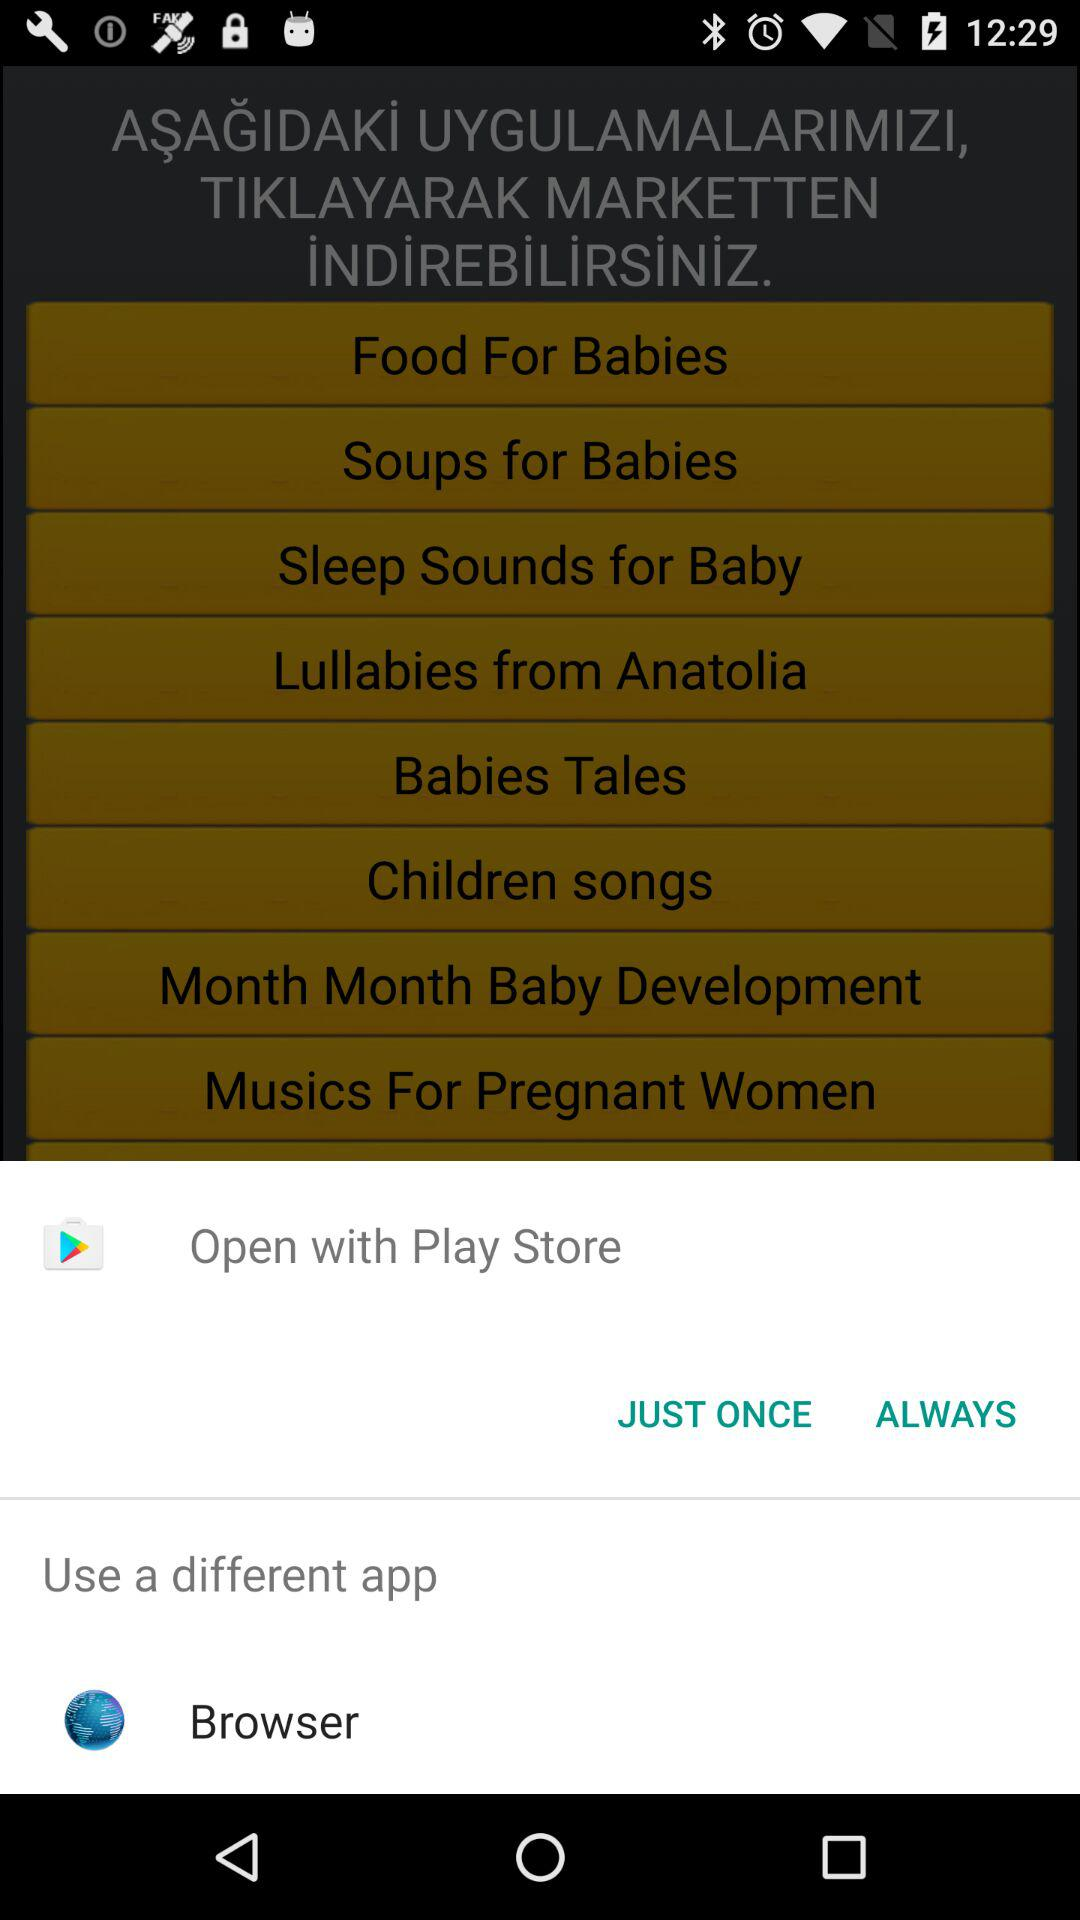How many applications are there for babies?
Answer the question using a single word or phrase. 8 